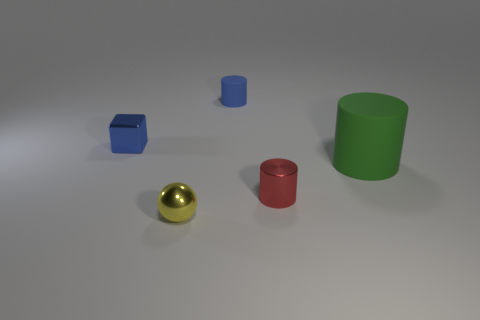What number of cyan objects are either rubber things or small shiny things?
Your response must be concise. 0. How many blue objects are both to the right of the shiny block and in front of the blue matte thing?
Your answer should be very brief. 0. Is the small blue cylinder made of the same material as the blue block?
Ensure brevity in your answer.  No. There is a blue matte thing that is the same size as the red cylinder; what is its shape?
Offer a very short reply. Cylinder. Is the number of big green cubes greater than the number of cylinders?
Your answer should be very brief. No. There is a cylinder that is left of the large green rubber cylinder and behind the metal cylinder; what material is it?
Your response must be concise. Rubber. What number of other things are the same material as the big green thing?
Offer a terse response. 1. What number of other matte cylinders have the same color as the large cylinder?
Keep it short and to the point. 0. There is a matte thing in front of the matte cylinder that is to the left of the cylinder that is on the right side of the red shiny cylinder; how big is it?
Keep it short and to the point. Large. What number of metallic things are either large blue spheres or small blue cubes?
Offer a terse response. 1. 